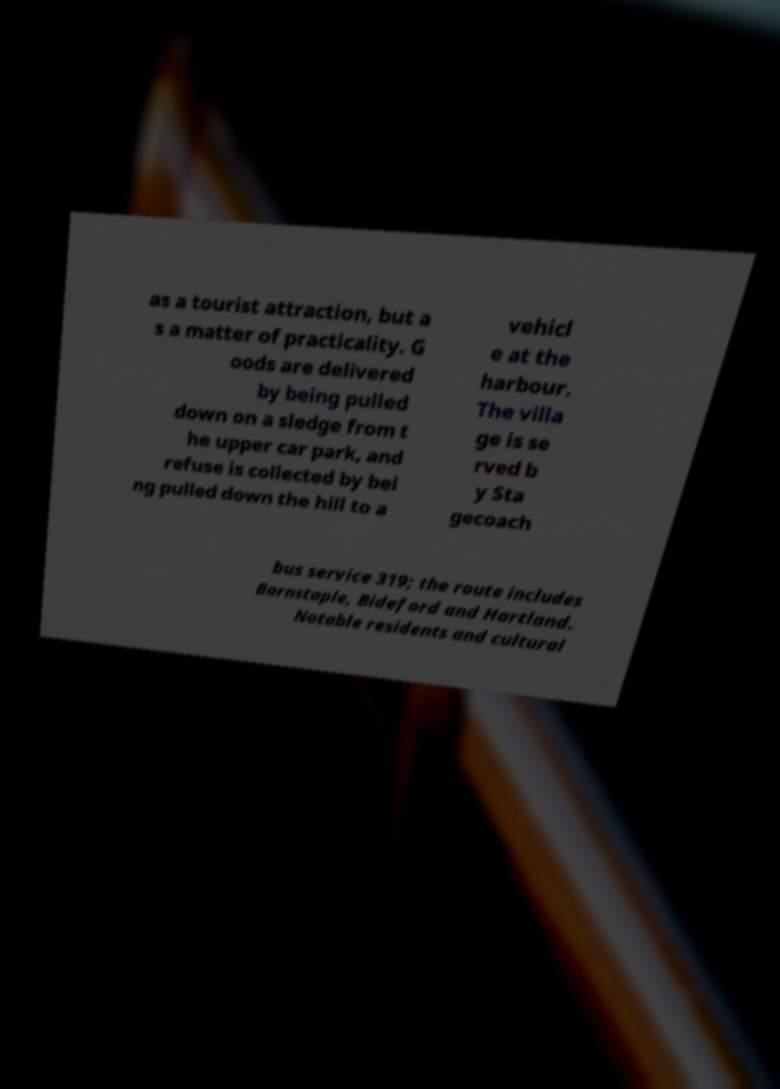Can you accurately transcribe the text from the provided image for me? as a tourist attraction, but a s a matter of practicality. G oods are delivered by being pulled down on a sledge from t he upper car park, and refuse is collected by bei ng pulled down the hill to a vehicl e at the harbour. The villa ge is se rved b y Sta gecoach bus service 319; the route includes Barnstaple, Bideford and Hartland. Notable residents and cultural 